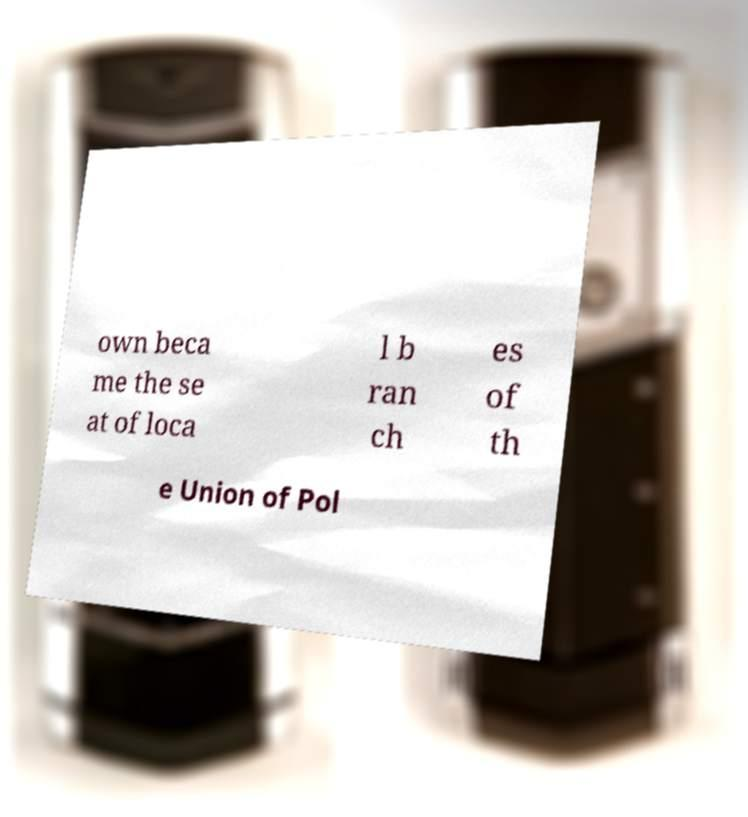Please read and relay the text visible in this image. What does it say? own beca me the se at of loca l b ran ch es of th e Union of Pol 